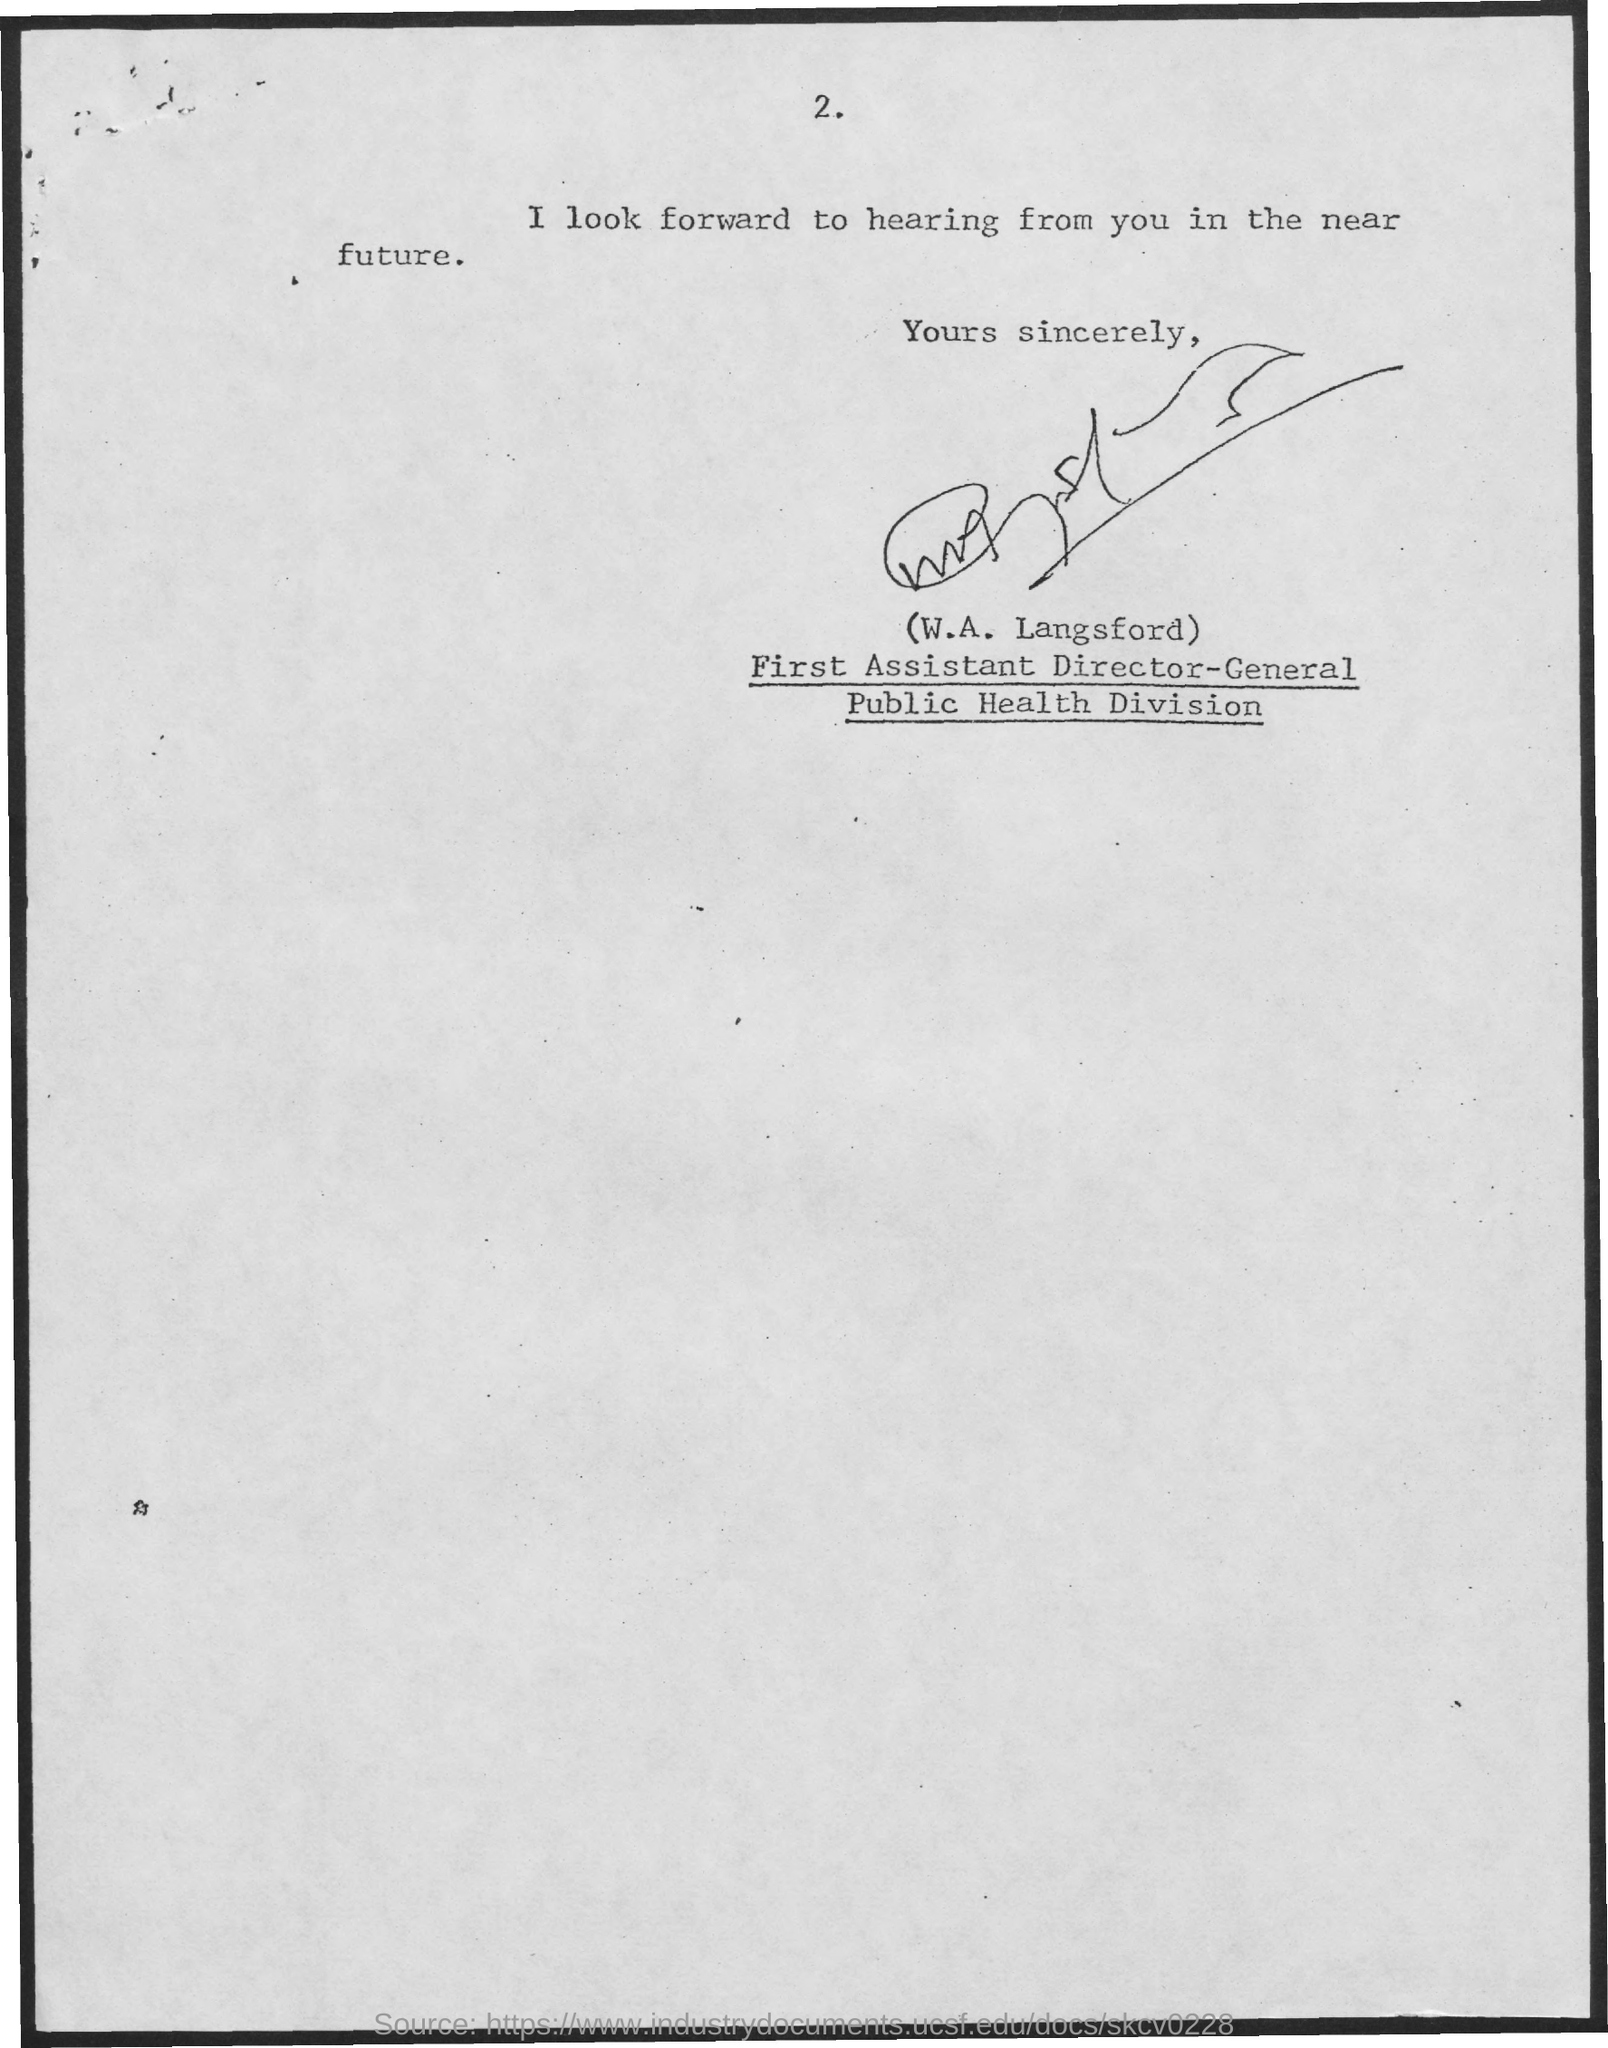Mention a couple of crucial points in this snapshot. The page number is 2, as declared. The First Assistant Director-General in the Public Health Division is W.A. Langsford. 